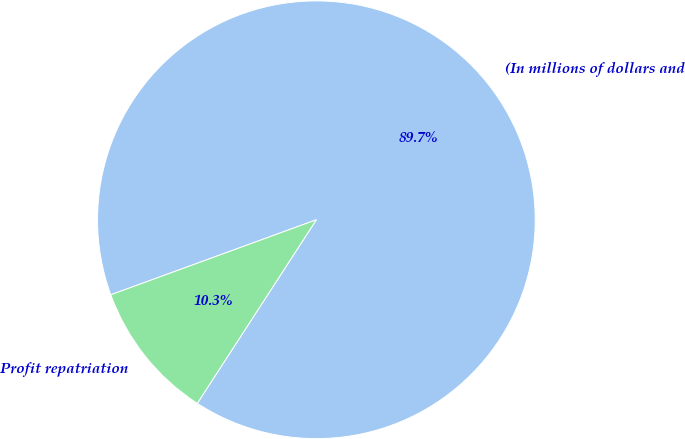Convert chart to OTSL. <chart><loc_0><loc_0><loc_500><loc_500><pie_chart><fcel>(In millions of dollars and<fcel>Profit repatriation<nl><fcel>89.73%<fcel>10.27%<nl></chart> 